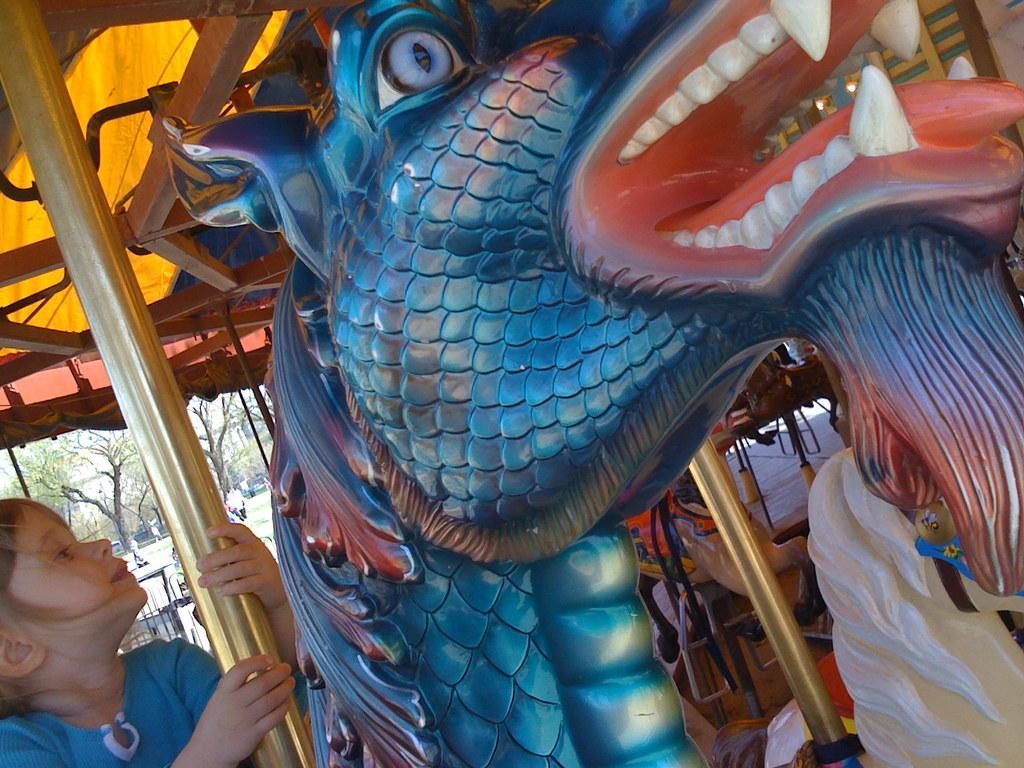In one or two sentences, can you explain what this image depicts? This image is taken outdoors. In the middle of the image there is a carnival dragon and a kid sat on the dragon. There are a few poles. At the top of the image there is a tent. There are a few trees and a few vehicles are parked on the ground. A few are walking on the ground. 